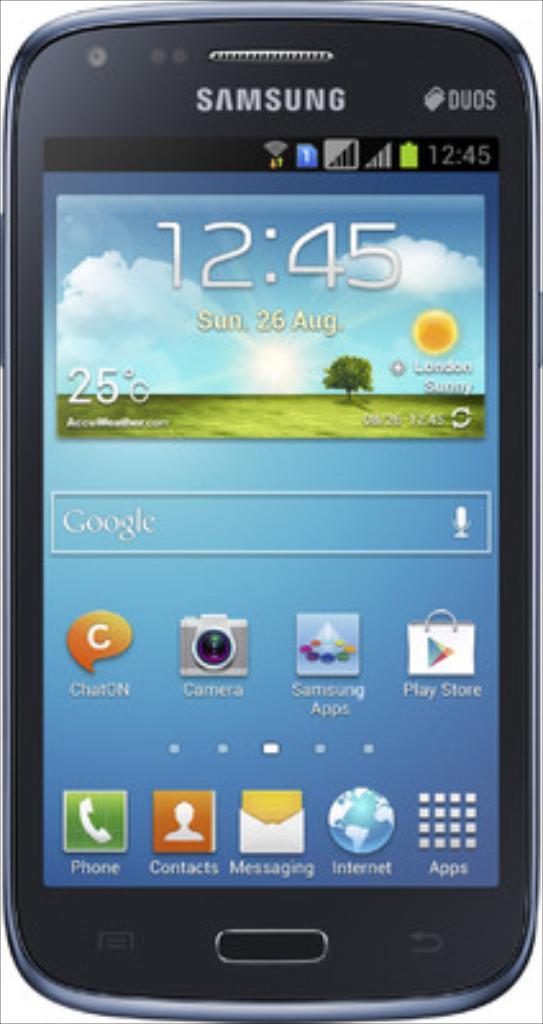What brand of smartphone is this?
Provide a succinct answer. Samsung. 